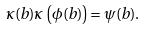Convert formula to latex. <formula><loc_0><loc_0><loc_500><loc_500>\kappa ( b ) \kappa \left ( \phi ( b ) \right ) = \psi ( b ) .</formula> 